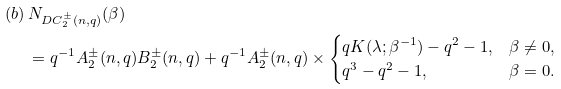<formula> <loc_0><loc_0><loc_500><loc_500>( b ) \, & N _ { D C _ { 2 } ^ { \pm } ( n , q ) } ( \beta ) \\ & = q ^ { - 1 } A _ { 2 } ^ { \pm } ( n , q ) B _ { 2 } ^ { \pm } ( n , q ) + q ^ { - 1 } A _ { 2 } ^ { \pm } ( n , q ) \times \begin{cases} q K ( \lambda ; \beta ^ { - 1 } ) - q ^ { 2 } - 1 , & \beta \neq 0 , \\ q ^ { 3 } - q ^ { 2 } - 1 , & \beta = 0 . \end{cases}</formula> 